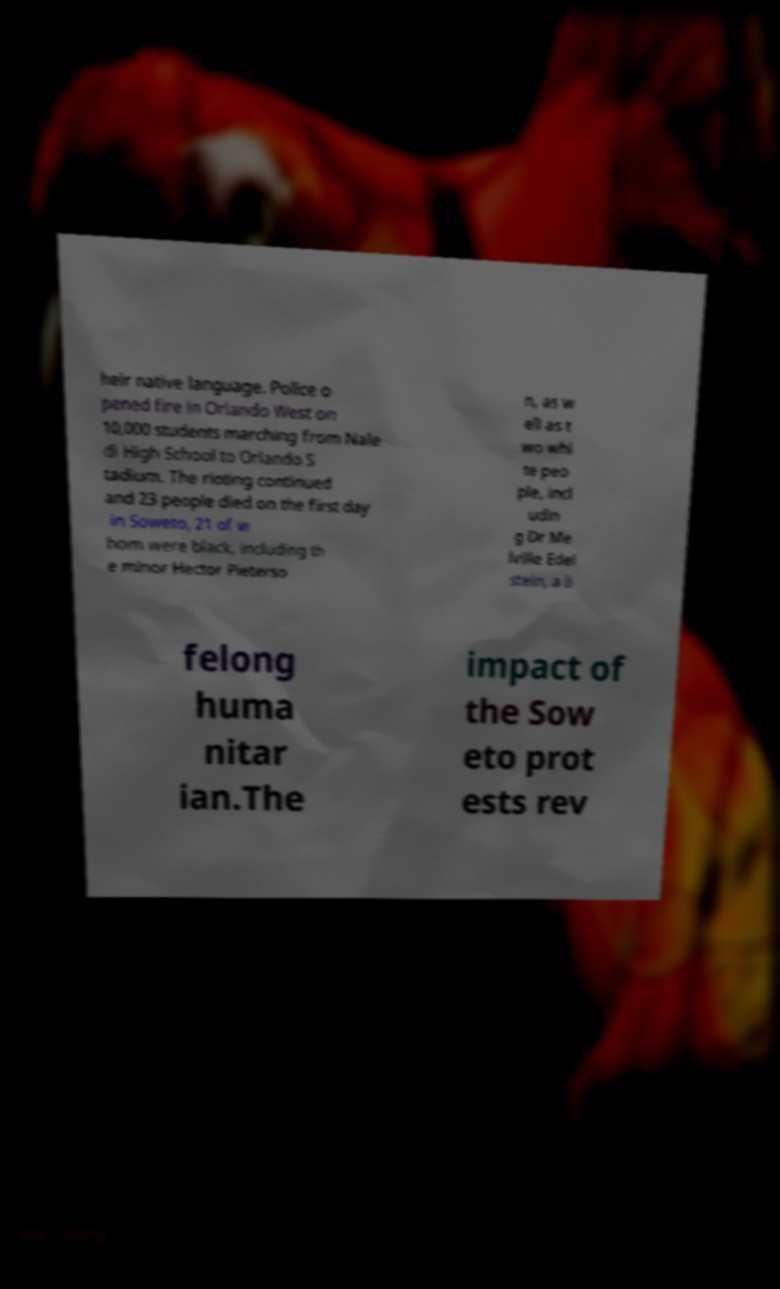What messages or text are displayed in this image? I need them in a readable, typed format. heir native language. Police o pened fire in Orlando West on 10,000 students marching from Nale di High School to Orlando S tadium. The rioting continued and 23 people died on the first day in Soweto, 21 of w hom were black, including th e minor Hector Pieterso n, as w ell as t wo whi te peo ple, incl udin g Dr Me lville Edel stein, a li felong huma nitar ian.The impact of the Sow eto prot ests rev 